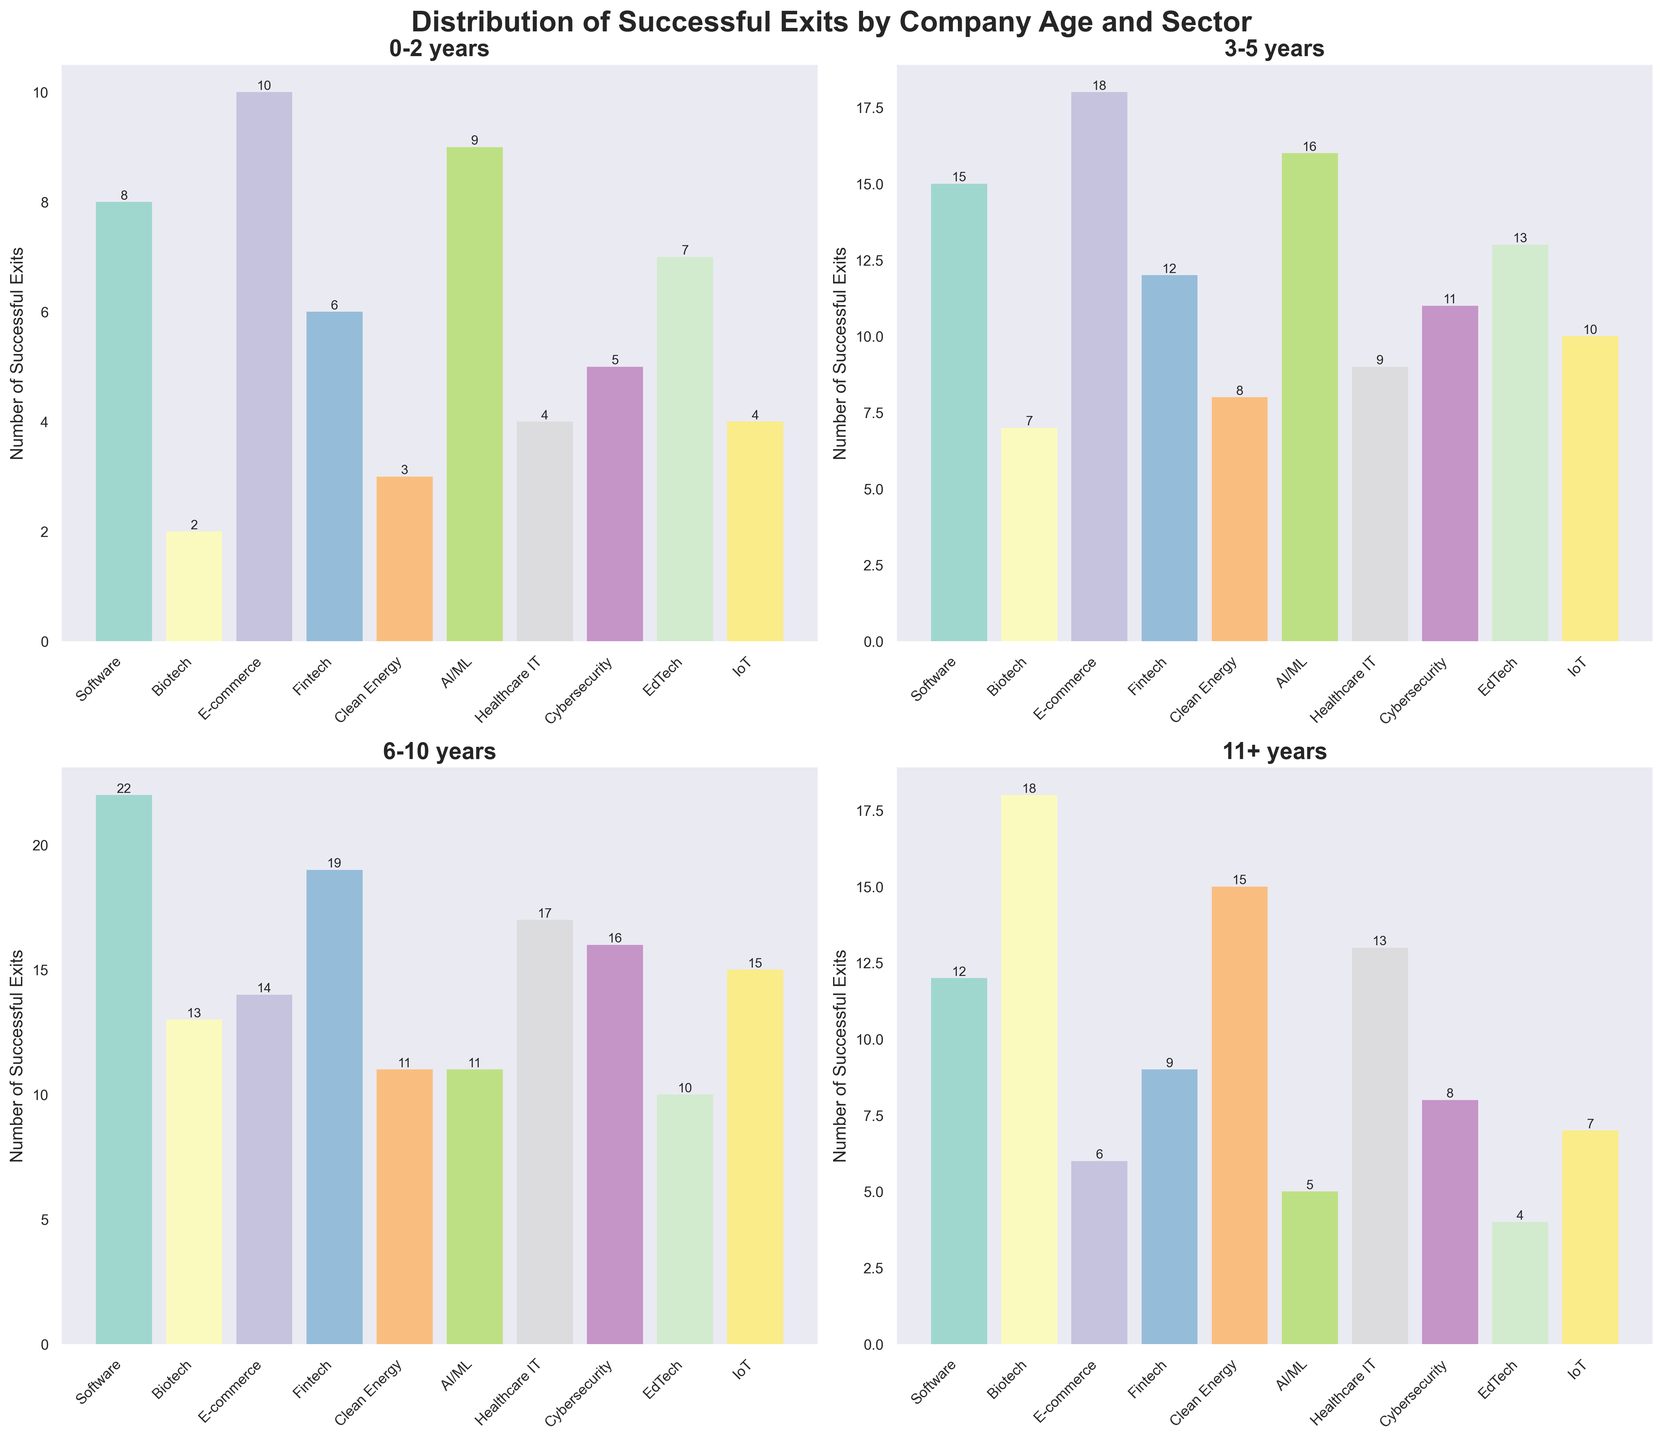What is the total number of successful exits in the Clean Energy sector for companies aged 6-10 years and 11+ years? Add the number of exits for Clean Energy in the 6-10 years category (11) and the 11+ years category (15). So, 11 + 15 = 26.
Answer: 26 Which sector had the highest number of successful exits for companies aged 3-5 years? Look at the 3-5 years subplot and compare the bar heights. E-commerce has the highest bar with 18 exits.
Answer: E-commerce How many more successful exits did the Software sector have for the 6-10 years age group compared to the 0-2 years age group? Subtract the number of exits in the 0-2 years group (8) from the number in the 6-10 years group (22). So, 22 - 8 = 14.
Answer: 14 Which age group had the fewest successful exits across all sectors combined? Sum the number of exits across all sectors for each age group and compare. The sums are: 
(0-2 years: 58, 3-5 years: 119, 6-10 years: 148, 11+ years: 97). One can see that the 0-2 years age group has the fewest exits.
Answer: 0-2 years What is the average number of successful exits for the AI/ML sector across all age groups? Add the number of exits across all age groups for AI/ML (9 + 16 + 11 + 5 = 41), then divide by the number of age groups (4). So, 41 / 4 = 10.25.
Answer: 10.25 Between Biotech and Fintech sectors, which one had more exits for companies aged 11+ years and by how many? Compare the exits for Biotech (18) and Fintech (9) in the 11+ years category. Biotech has more exits. Subtract Fintech exits from Biotech exits: 18 - 9 = 9.
Answer: Biotech, 9 In which age group does the IoT sector have its maximum number of successful exits? Look at the bars for the IoT sector across all age groups. IoT has the highest bar in the 6-10 years category with 15 exits.
Answer: 6-10 years How many sectors had more than 10 successful exits for companies aged 0-2 years? Count the number of sectors with bars greater than 10 in the 0-2 years category. There are two sectors: E-commerce (10) and AI/ML (9).
Answer: 2 Which sector had the highest variance in the number of successful exits across all age groups? Calculate the variance for each sector and compare. By visually inspecting, E-commerce has the highest difference between its highest (18) and lowest values (6), implying it has the highest variance.
Answer: E-commerce What is the total number of sectors having at least one age group with more than 13 successful exits? Count the sectors where at least one age group bar height is greater than 13. The sectors are Software, Biotech, E-commerce, Fintech, AI/ML, Healthcare IT, Cybersecurity (7 total).
Answer: 7 